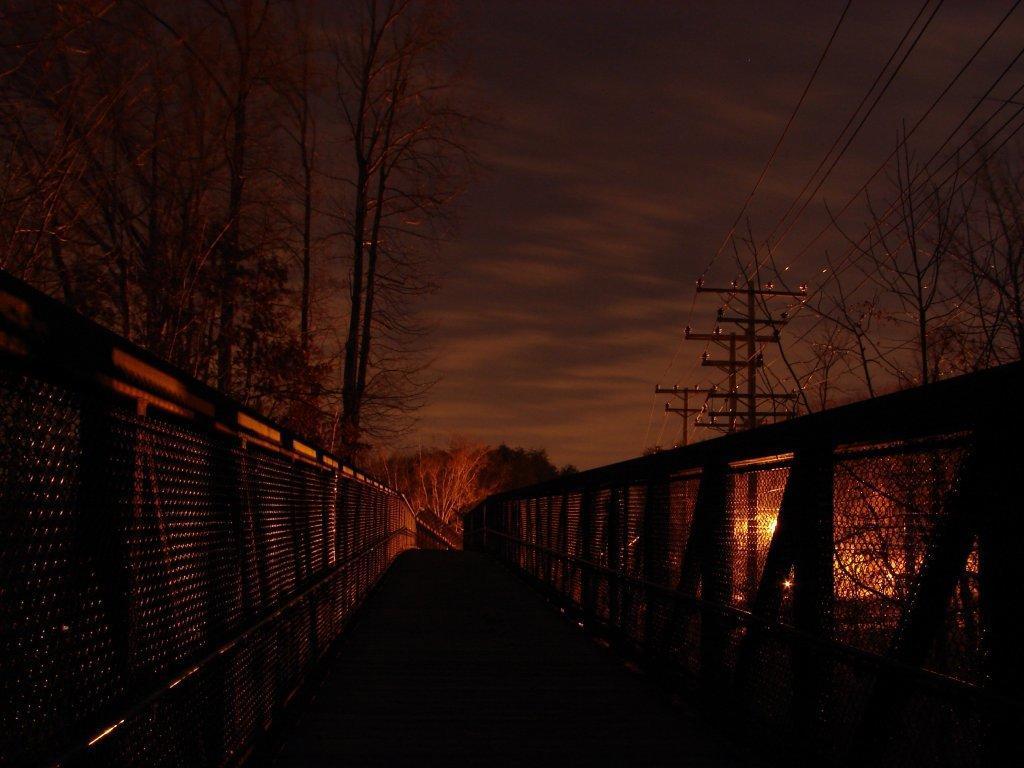Please provide a concise description of this image. In this image there is a bridge. On the right and left side of the bridge there is a railing. In the background there are trees, utility poles and the sky. 